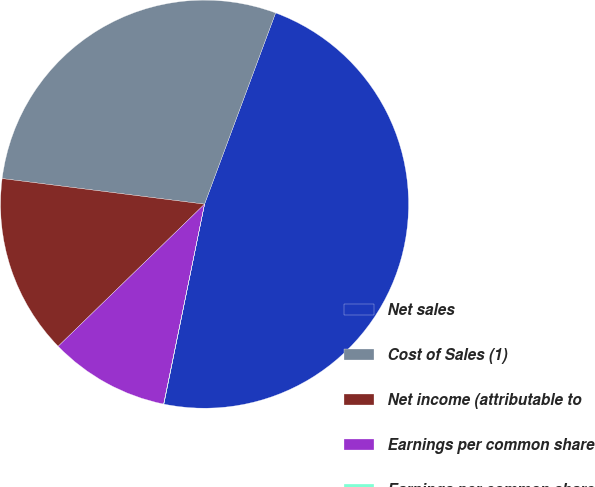Convert chart to OTSL. <chart><loc_0><loc_0><loc_500><loc_500><pie_chart><fcel>Net sales<fcel>Cost of Sales (1)<fcel>Net income (attributable to<fcel>Earnings per common share<fcel>Earnings per common share -<nl><fcel>47.53%<fcel>28.66%<fcel>14.27%<fcel>9.52%<fcel>0.02%<nl></chart> 